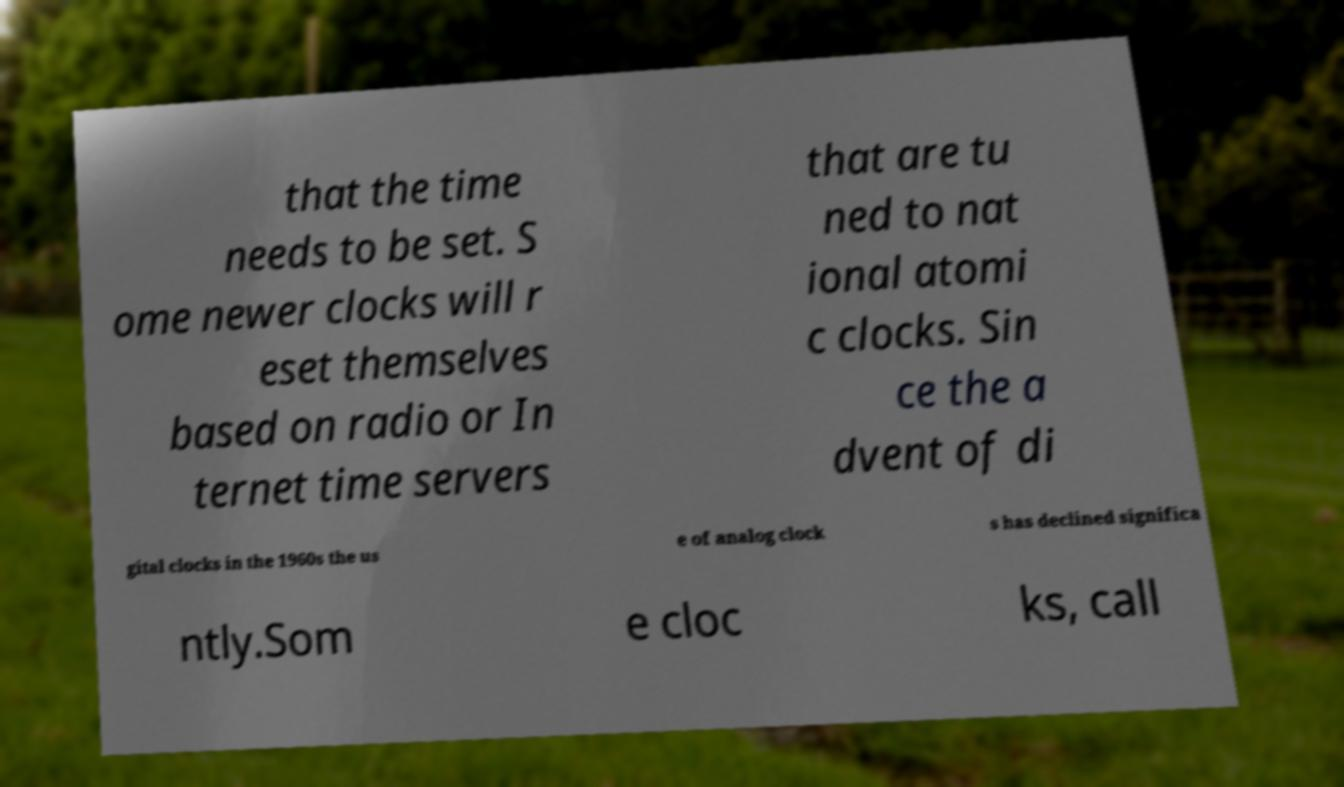For documentation purposes, I need the text within this image transcribed. Could you provide that? that the time needs to be set. S ome newer clocks will r eset themselves based on radio or In ternet time servers that are tu ned to nat ional atomi c clocks. Sin ce the a dvent of di gital clocks in the 1960s the us e of analog clock s has declined significa ntly.Som e cloc ks, call 